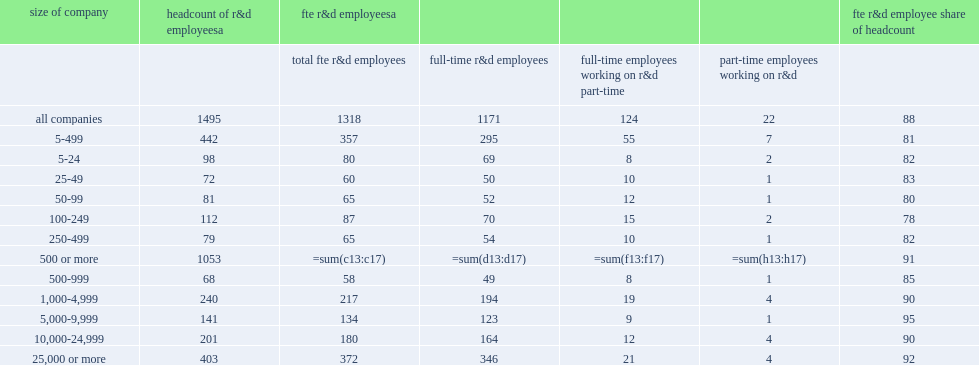How mnay thousand fte did businesses have domestic r&d employees in 2013? 1318.0. Businesses had 1.3 million fte domestic r&d employees in 2013, how many percent of the headcount estimate from the survey? 0.881605. 